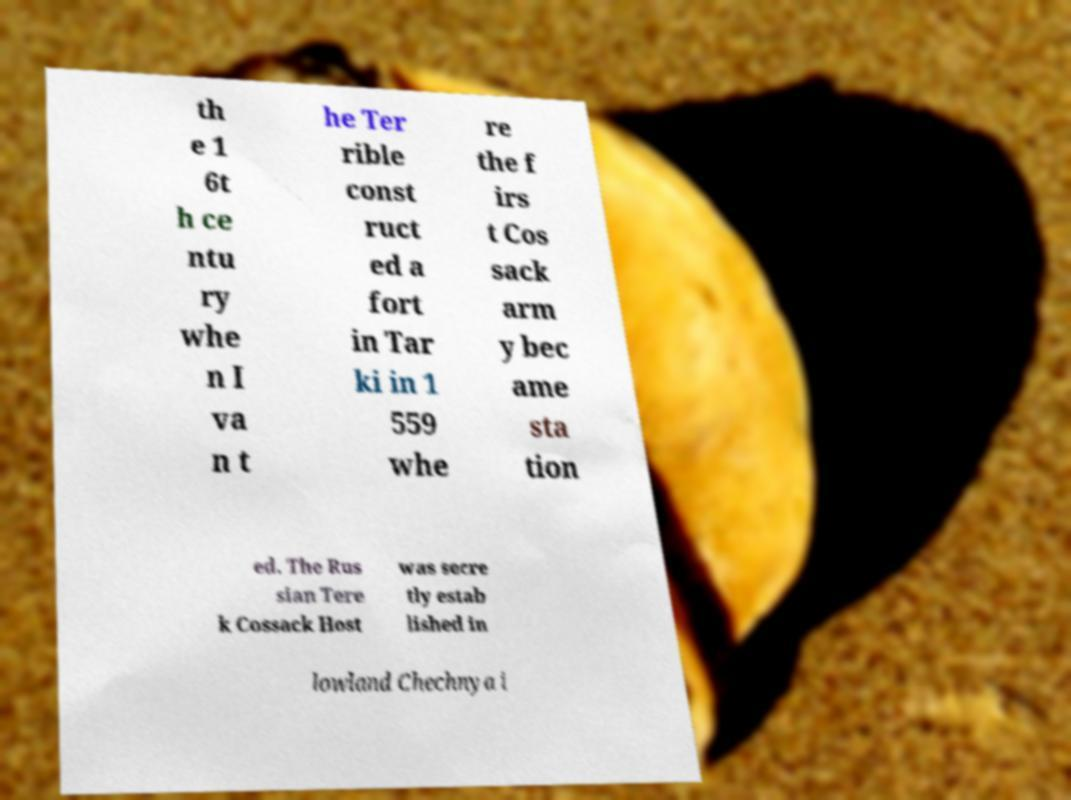For documentation purposes, I need the text within this image transcribed. Could you provide that? th e 1 6t h ce ntu ry whe n I va n t he Ter rible const ruct ed a fort in Tar ki in 1 559 whe re the f irs t Cos sack arm y bec ame sta tion ed. The Rus sian Tere k Cossack Host was secre tly estab lished in lowland Chechnya i 